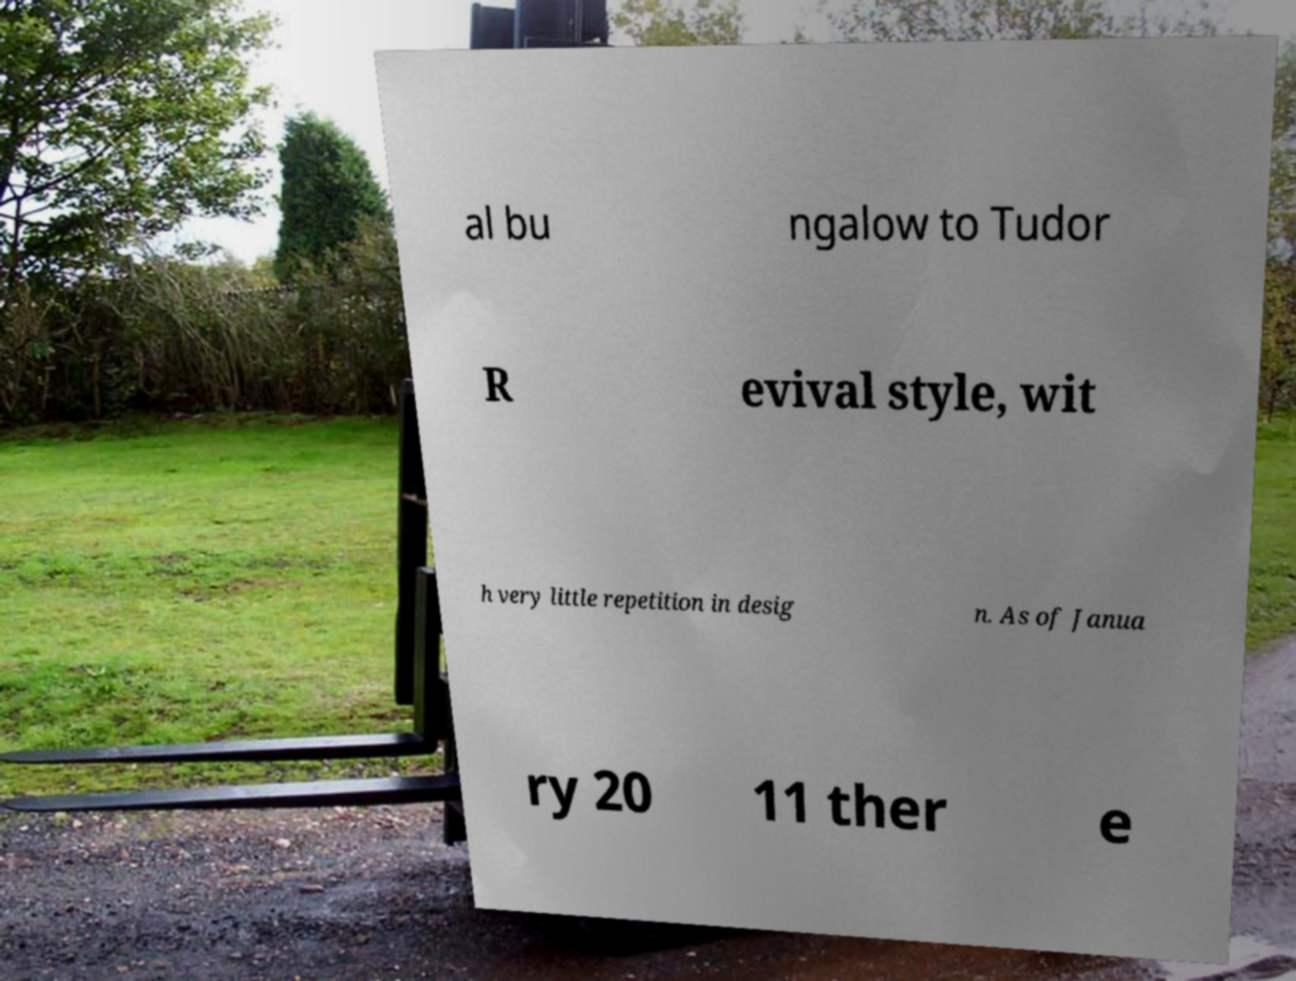Could you assist in decoding the text presented in this image and type it out clearly? al bu ngalow to Tudor R evival style, wit h very little repetition in desig n. As of Janua ry 20 11 ther e 